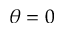<formula> <loc_0><loc_0><loc_500><loc_500>\theta = 0</formula> 